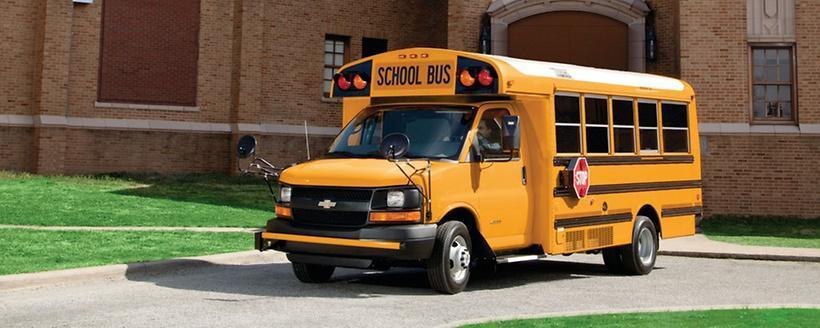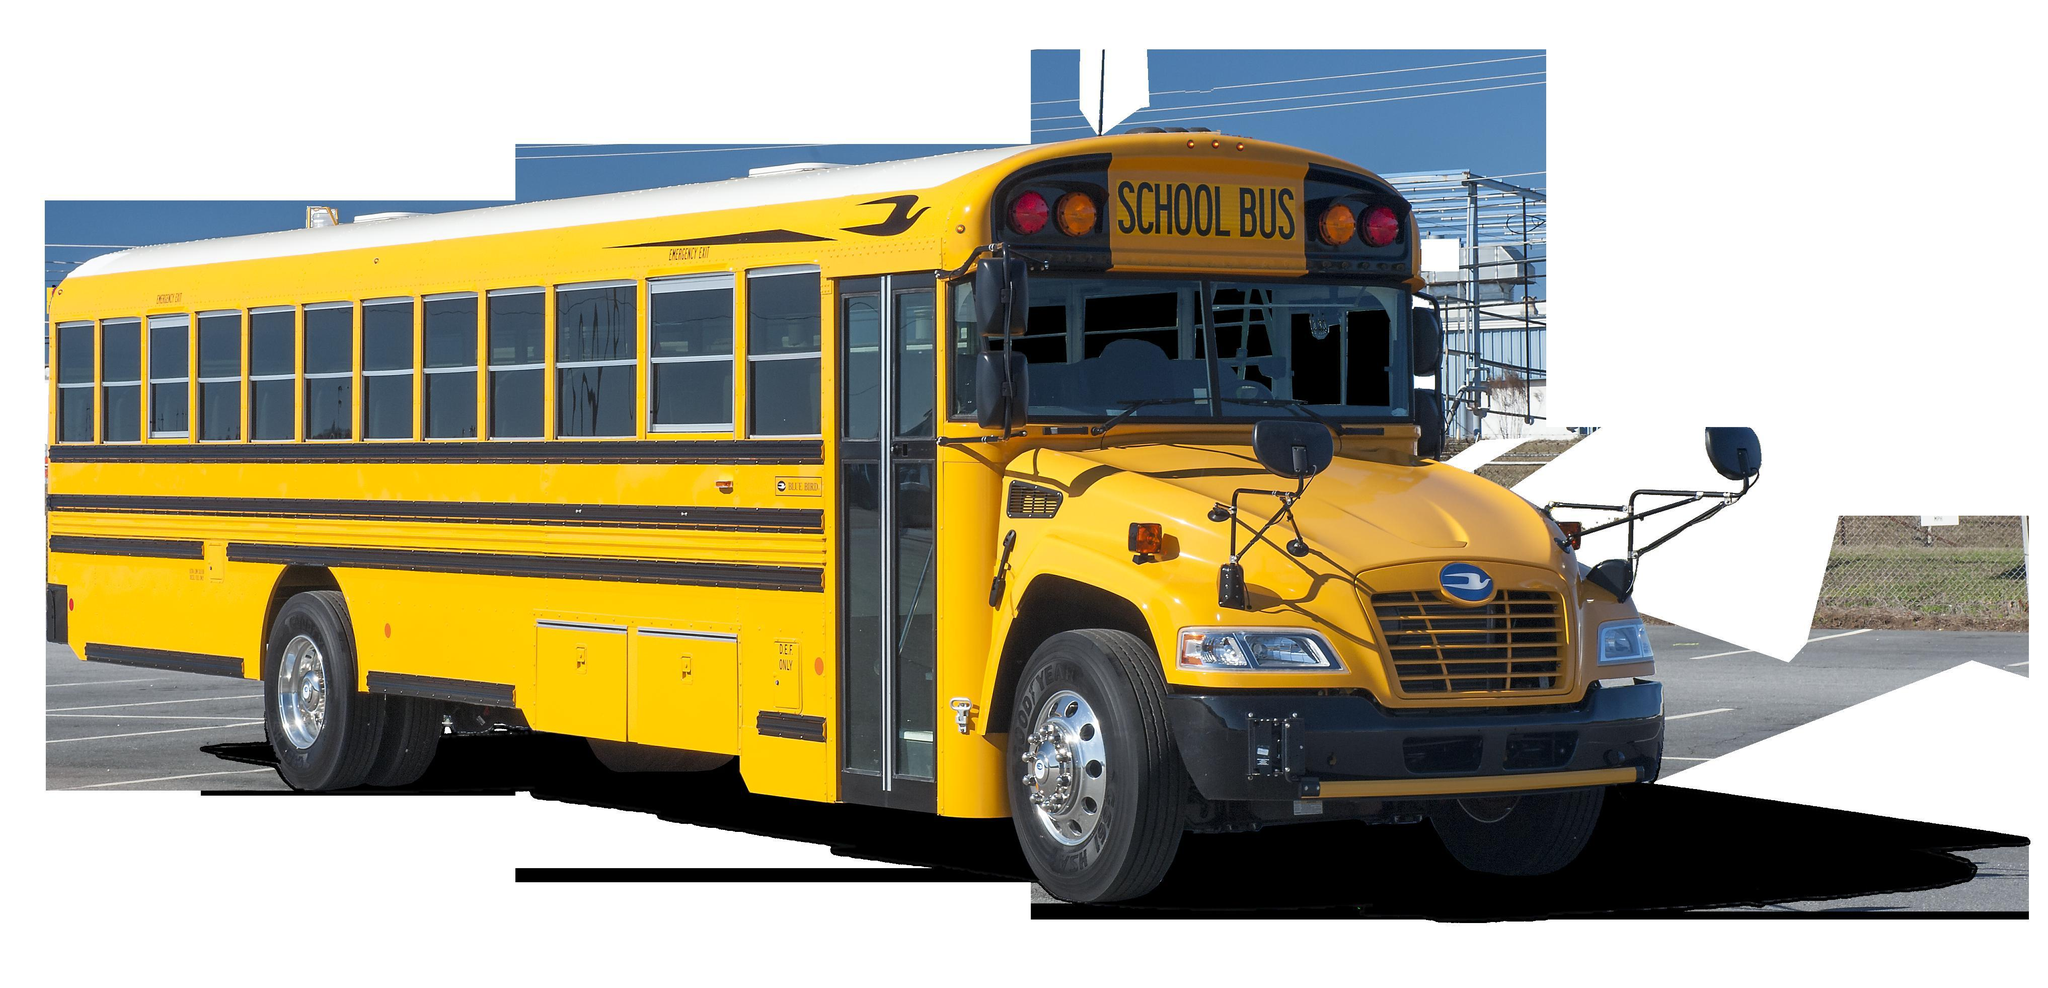The first image is the image on the left, the second image is the image on the right. Analyze the images presented: Is the assertion "Each image contains at least one flat-fronted yellow bus, and the bus in the right image is angled rightward." valid? Answer yes or no. No. The first image is the image on the left, the second image is the image on the right. Given the left and right images, does the statement "There is one bus pointing left in the left image." hold true? Answer yes or no. Yes. 